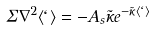Convert formula to latex. <formula><loc_0><loc_0><loc_500><loc_500>\Sigma \nabla ^ { 2 } \langle \ell \rangle = - A _ { s } \tilde { \kappa } e ^ { - \tilde { \kappa } \langle \ell \rangle }</formula> 